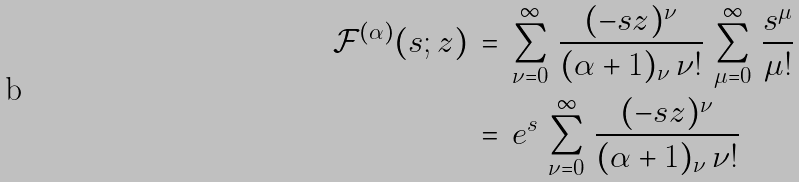<formula> <loc_0><loc_0><loc_500><loc_500>\mathcal { F } ^ { ( \alpha ) } ( s ; z ) & \, = \, \sum _ { \nu = 0 } ^ { \infty } \, \frac { ( - s z ) ^ { \nu } } { ( \alpha + 1 ) _ { \nu } \, \nu ! } \, \sum _ { \mu = 0 } ^ { \infty } \, \frac { s ^ { \mu } } { \mu ! } \\ & \, = \, e ^ { s } \, \sum _ { \nu = 0 } ^ { \infty } \, \frac { ( - s z ) ^ { \nu } } { ( \alpha + 1 ) _ { \nu } \, \nu ! }</formula> 